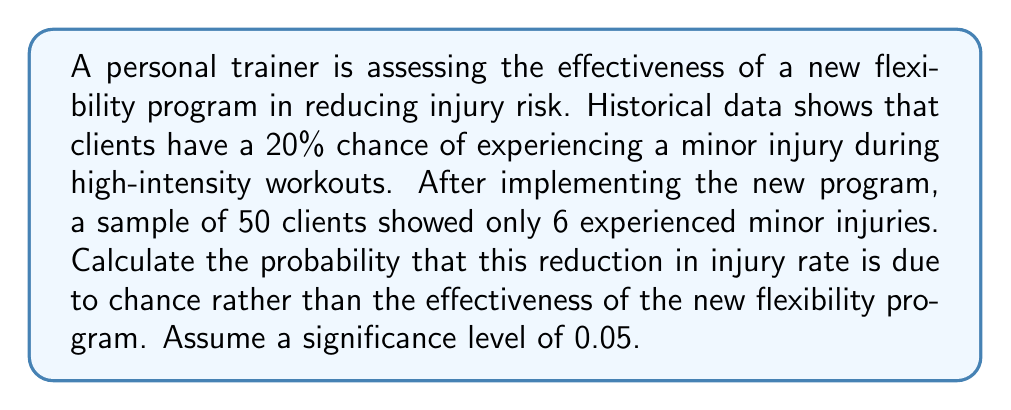Solve this math problem. Let's approach this step-by-step using a hypothesis test:

1) Define null and alternative hypotheses:
   $H_0: p = 0.20$ (The injury rate is unchanged)
   $H_a: p < 0.20$ (The injury rate has decreased)

2) Calculate the sample proportion:
   $\hat{p} = \frac{6}{50} = 0.12$

3) Calculate the test statistic (z-score):
   $$z = \frac{\hat{p} - p_0}{\sqrt{\frac{p_0(1-p_0)}{n}}}$$
   $$z = \frac{0.12 - 0.20}{\sqrt{\frac{0.20(1-0.20)}{50}}} = -1.58$$

4) Find the p-value:
   The p-value is the probability of obtaining a z-score as extreme as or more extreme than -1.58 under the null hypothesis.
   Using a standard normal distribution table or calculator:
   $p-value = P(Z \leq -1.58) = 0.0571$

5) Compare the p-value to the significance level:
   $0.0571 > 0.05$

6) Interpretation:
   Since the p-value is greater than the significance level, we fail to reject the null hypothesis. This means there's insufficient evidence to conclude that the new flexibility program significantly reduced the injury rate.

The probability that this reduction in injury rate is due to chance rather than the effectiveness of the new program is 0.0571 or 5.71%.
Answer: 0.0571 